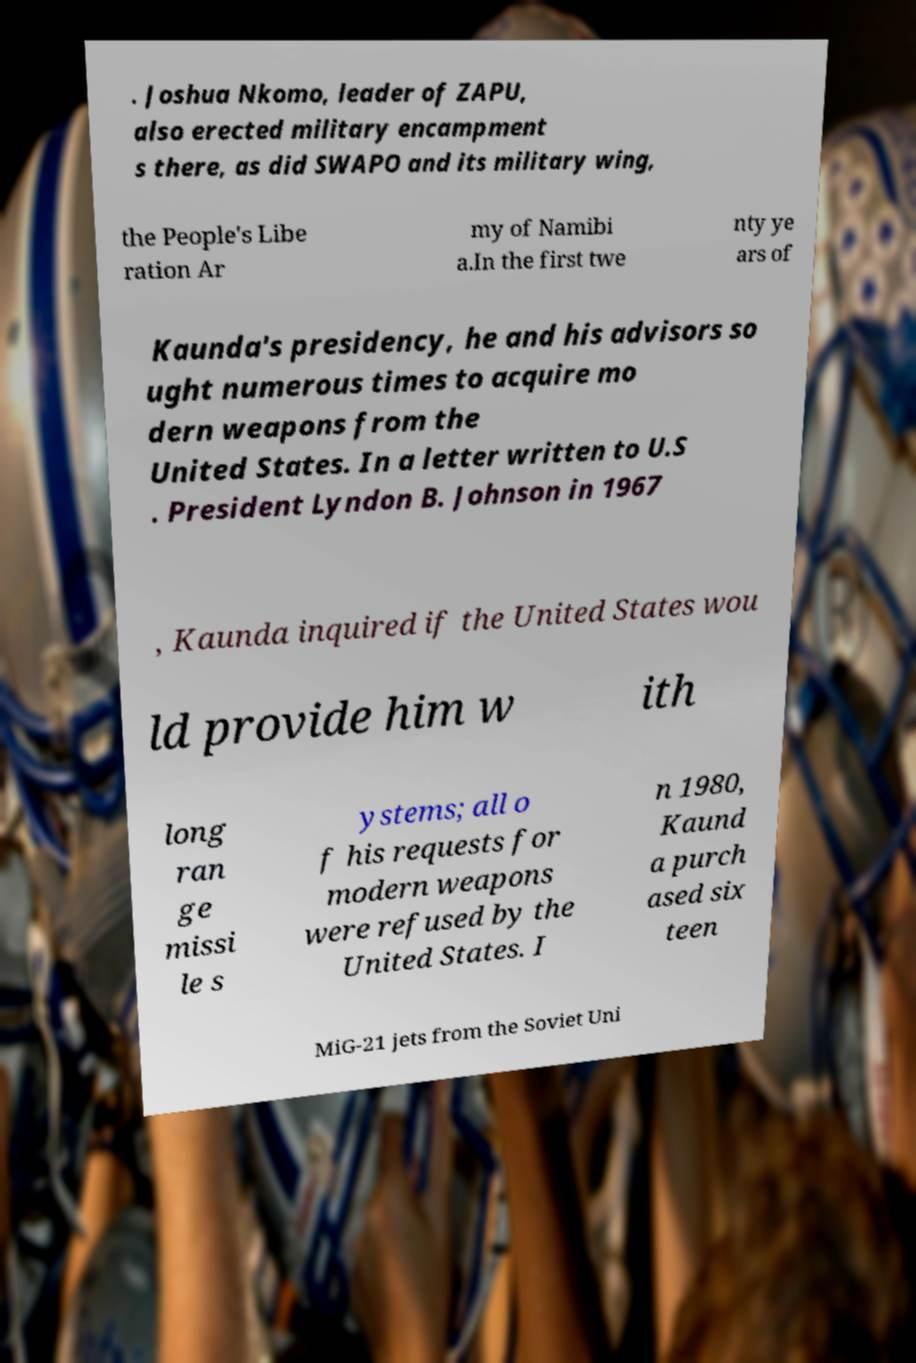There's text embedded in this image that I need extracted. Can you transcribe it verbatim? . Joshua Nkomo, leader of ZAPU, also erected military encampment s there, as did SWAPO and its military wing, the People's Libe ration Ar my of Namibi a.In the first twe nty ye ars of Kaunda's presidency, he and his advisors so ught numerous times to acquire mo dern weapons from the United States. In a letter written to U.S . President Lyndon B. Johnson in 1967 , Kaunda inquired if the United States wou ld provide him w ith long ran ge missi le s ystems; all o f his requests for modern weapons were refused by the United States. I n 1980, Kaund a purch ased six teen MiG-21 jets from the Soviet Uni 